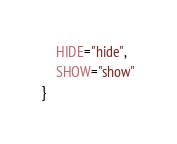Convert code to text. <code><loc_0><loc_0><loc_500><loc_500><_TypeScript_>    HIDE="hide",
    SHOW="show"
}
</code> 